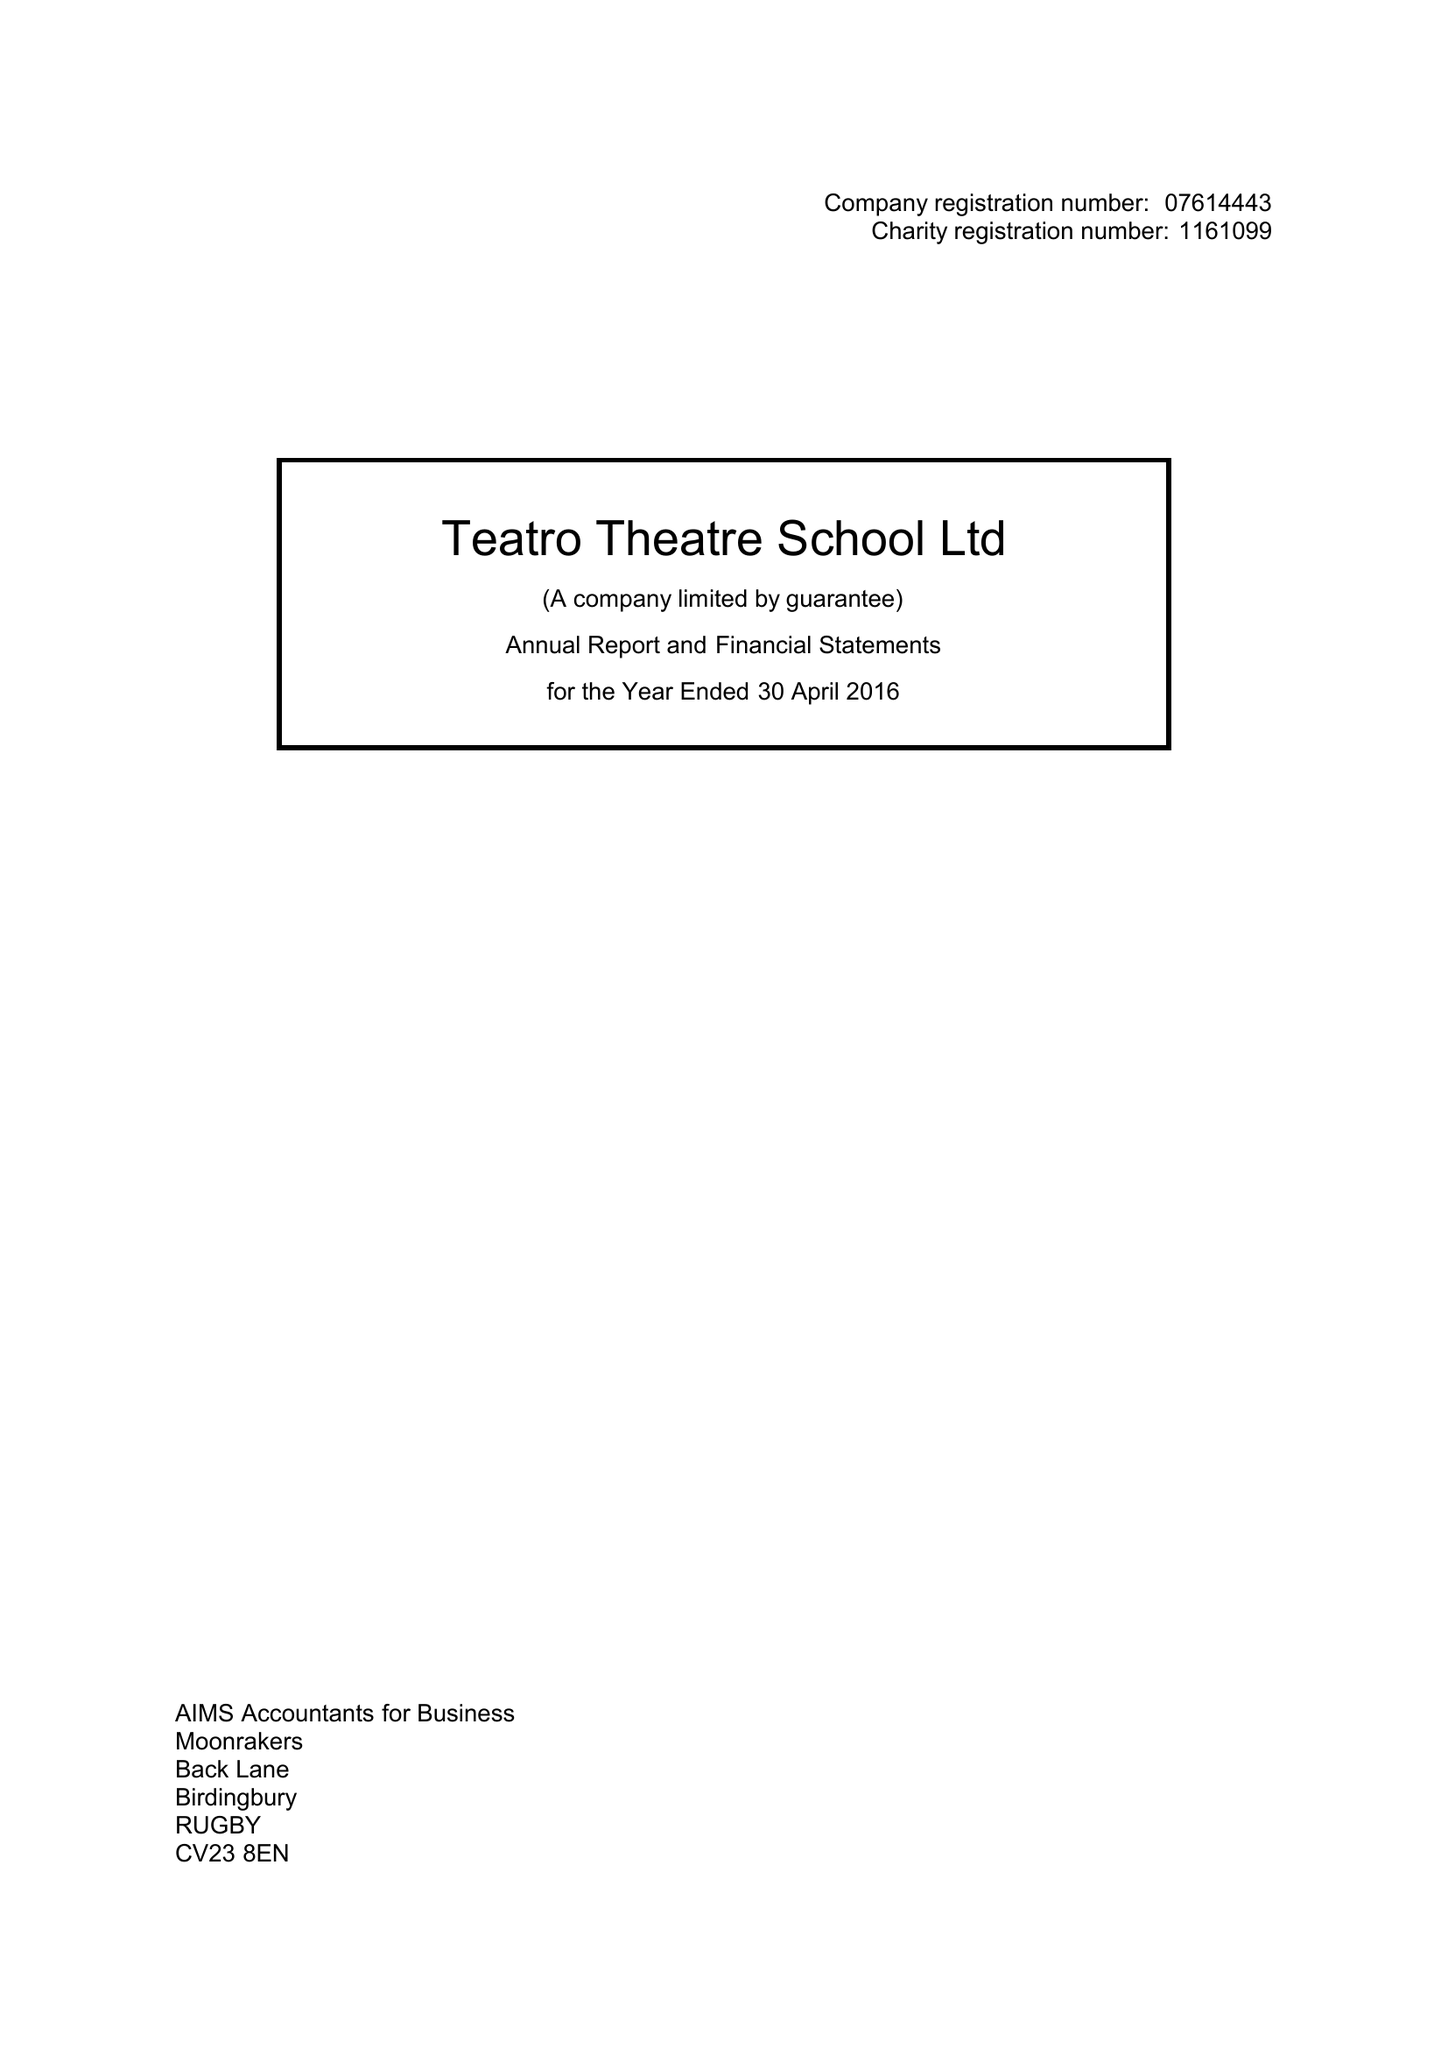What is the value for the address__street_line?
Answer the question using a single word or phrase. 67 GROVE STREET 